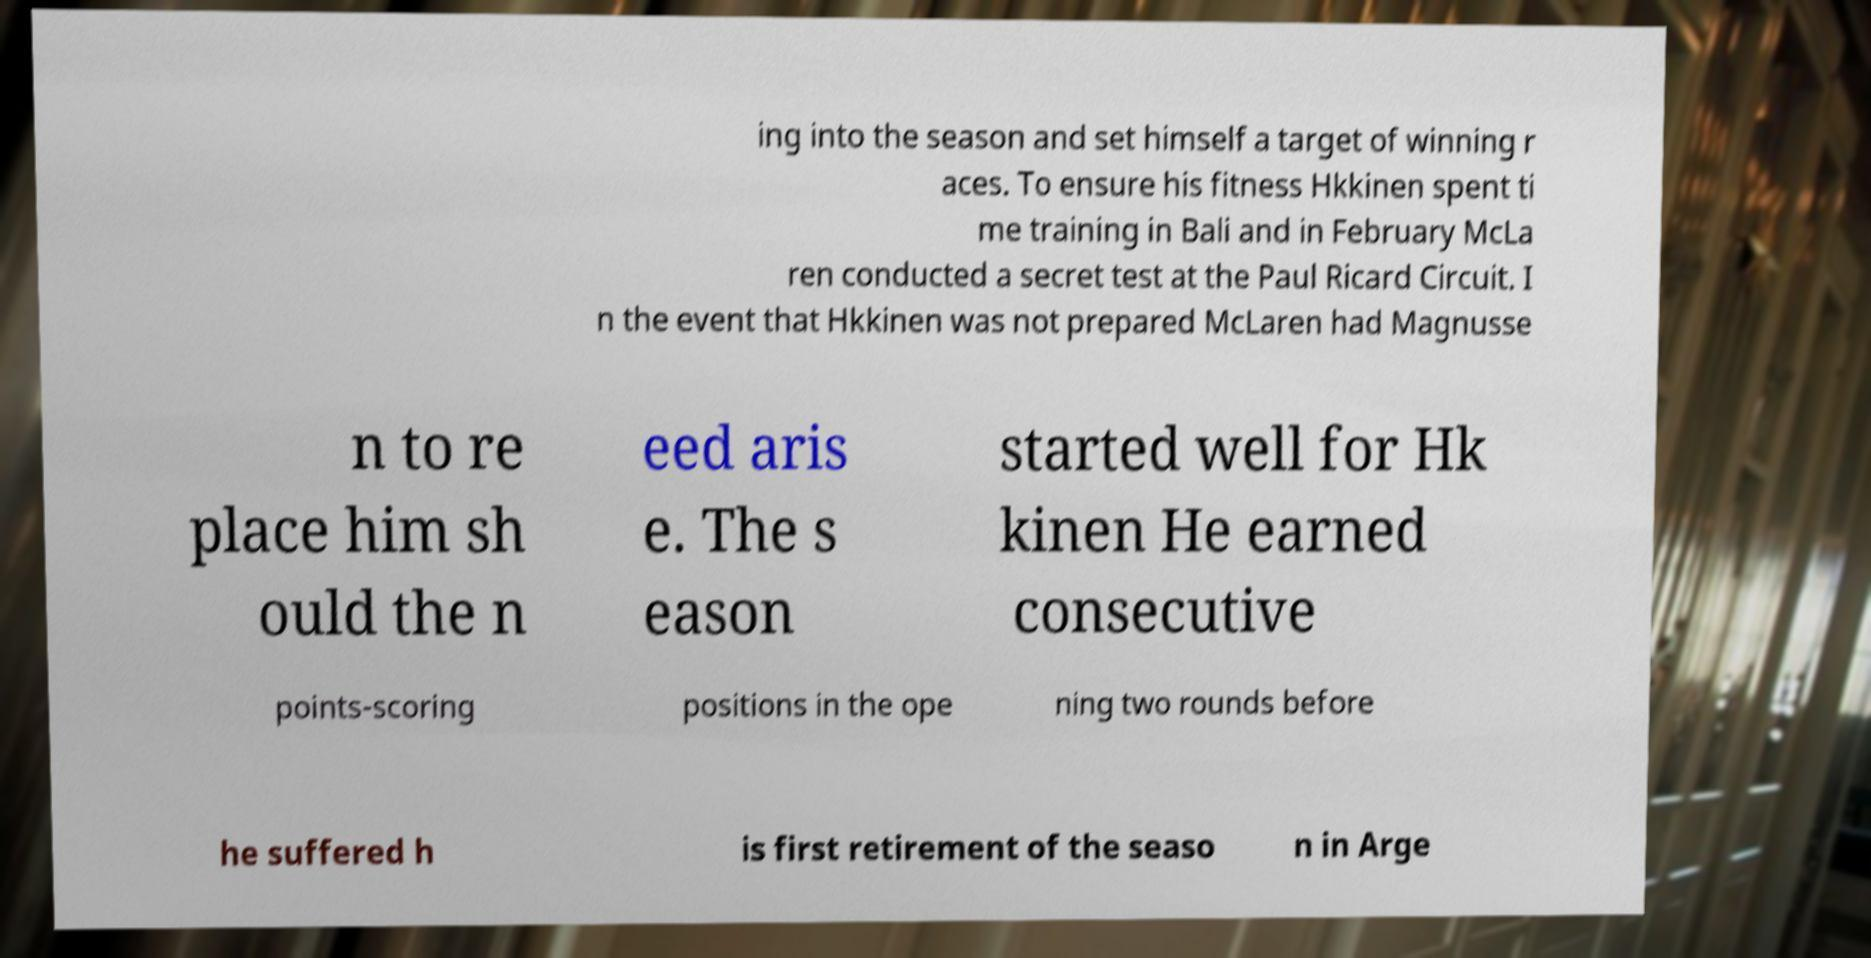There's text embedded in this image that I need extracted. Can you transcribe it verbatim? ing into the season and set himself a target of winning r aces. To ensure his fitness Hkkinen spent ti me training in Bali and in February McLa ren conducted a secret test at the Paul Ricard Circuit. I n the event that Hkkinen was not prepared McLaren had Magnusse n to re place him sh ould the n eed aris e. The s eason started well for Hk kinen He earned consecutive points-scoring positions in the ope ning two rounds before he suffered h is first retirement of the seaso n in Arge 